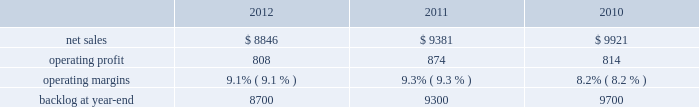Aeronautics 2019 operating profit for 2011 increased $ 132 million , or 9% ( 9 % ) , compared to 2010 .
The increase primarily was attributable to approximately $ 115 million of higher operating profit on c-130 programs due to increased volume and the retirement of risks ; increased volume and risk retirements on f-16 programs of about $ 50 million and c-5 programs of approximately $ 20 million ; and about $ 70 million due to risk retirements on other aeronautics sustainment activities in 2011 .
These increases partially were offset by a decline in operating profit of approximately $ 75 million on the f-22 program and f-35 development contract primarily due to lower volume and about $ 55 million on other programs , including f-35 lrip , primarily due to lower profit rate adjustments in 2011 compared to 2010 .
Adjustments not related to volume , including net profit rate adjustments described above , were approximately $ 90 million higher in 2011 compared to 2010 .
Backlog backlog decreased in 2012 compared to 2011 mainly due to lower orders on f-35 contracts and c-130 programs , partially offset by higher orders on f-16 programs .
Backlog increased in 2011 compared to 2010 mainly due to higher orders on f-35 contracts , which partially were offset by higher sales volume on the c-130 programs .
Trends we expect aeronautics will experience a mid single digit percentage range decline in net sales for 2013 as compared to 2012 .
A decrease in net sales from a decline in f-16 and c-130j aircraft deliveries is expected to be partially offset by an increase in net sales volume on f-35 lrip contracts .
Operating profit is projected to decrease at a high single digit percentage range from 2012 levels due to the expected decline in net sales as well as changes in aircraft mix , resulting in a slight decline in operating margins between the years .
Information systems & global solutions our is&gs business segment provides management services , integrated information technology solutions , and advanced technology systems and expertise across a broad spectrum of applications for civil , defense , intelligence , and other government customers .
Is&gs has a portfolio of many smaller contracts as compared to our other business segments .
Is&gs has been impacted by the continuing downturn in the federal information technology budgets and the impact of the continuing resolution that was effective on october 1 , 2012 , the start of the u.s .
Government 2019s fiscal year .
Is&gs 2019 operating results included the following ( in millions ) : .
2012 compared to 2011 is&gs 2019 net sales for 2012 decreased $ 535 million , or 6% ( 6 % ) , compared to 2011 .
The decrease was attributable to lower net sales of approximately $ 485 million due to the substantial completion of various programs during 2011 ( primarily jtrs ; odin ; and u.k .
Census ) ; and about $ 255 million due to lower volume on numerous other programs ( primarily hanford ; warfighter information network-tactical ( win-t ) ; command , control , battle management and communications ( c2bmc ) ; and transportation worker identification credential ( twic ) ) .
Partially offsetting the decreases were higher net sales of approximately $ 140 million from qtc , which was acquired early in the fourth quarter of 2011 ; and about $ 65 million from increased activity on numerous other programs , primarily federal cyber security programs and persistent threat detection system ( ptds ) operational support .
Is&gs 2019 operating profit for 2012 decreased $ 66 million , or 8% ( 8 % ) , compared to 2011 .
The decrease was attributable to lower operating profit of approximately $ 50 million due to the favorable impact of the odin contract completion in 2011 ; about $ 25 million due to an increase in reserves for performance issues related to an international airborne surveillance system in 2012 ; and approximately $ 20 million due to lower volume on certain programs ( primarily c2bmc and win-t ) .
Partially offsetting the decreases was an increase in operating profit due to higher risk retirements of approximately $ 15 million from the twic program ; and about $ 10 million due to increased activity on numerous other programs , primarily federal cyber security programs and ptds operational support .
Operating profit for the jtrs program was comparable as a decrease in volume was offset by a decrease in reserves .
Adjustments not related to volume , including net profit booking rate adjustments and other matters described above , were approximately $ 20 million higher for 2012 compared to 2011. .
What is the growth rate in net sales for is&gs in 2012? 
Computations: (8846 - 9381)
Answer: -535.0. Aeronautics 2019 operating profit for 2011 increased $ 132 million , or 9% ( 9 % ) , compared to 2010 .
The increase primarily was attributable to approximately $ 115 million of higher operating profit on c-130 programs due to increased volume and the retirement of risks ; increased volume and risk retirements on f-16 programs of about $ 50 million and c-5 programs of approximately $ 20 million ; and about $ 70 million due to risk retirements on other aeronautics sustainment activities in 2011 .
These increases partially were offset by a decline in operating profit of approximately $ 75 million on the f-22 program and f-35 development contract primarily due to lower volume and about $ 55 million on other programs , including f-35 lrip , primarily due to lower profit rate adjustments in 2011 compared to 2010 .
Adjustments not related to volume , including net profit rate adjustments described above , were approximately $ 90 million higher in 2011 compared to 2010 .
Backlog backlog decreased in 2012 compared to 2011 mainly due to lower orders on f-35 contracts and c-130 programs , partially offset by higher orders on f-16 programs .
Backlog increased in 2011 compared to 2010 mainly due to higher orders on f-35 contracts , which partially were offset by higher sales volume on the c-130 programs .
Trends we expect aeronautics will experience a mid single digit percentage range decline in net sales for 2013 as compared to 2012 .
A decrease in net sales from a decline in f-16 and c-130j aircraft deliveries is expected to be partially offset by an increase in net sales volume on f-35 lrip contracts .
Operating profit is projected to decrease at a high single digit percentage range from 2012 levels due to the expected decline in net sales as well as changes in aircraft mix , resulting in a slight decline in operating margins between the years .
Information systems & global solutions our is&gs business segment provides management services , integrated information technology solutions , and advanced technology systems and expertise across a broad spectrum of applications for civil , defense , intelligence , and other government customers .
Is&gs has a portfolio of many smaller contracts as compared to our other business segments .
Is&gs has been impacted by the continuing downturn in the federal information technology budgets and the impact of the continuing resolution that was effective on october 1 , 2012 , the start of the u.s .
Government 2019s fiscal year .
Is&gs 2019 operating results included the following ( in millions ) : .
2012 compared to 2011 is&gs 2019 net sales for 2012 decreased $ 535 million , or 6% ( 6 % ) , compared to 2011 .
The decrease was attributable to lower net sales of approximately $ 485 million due to the substantial completion of various programs during 2011 ( primarily jtrs ; odin ; and u.k .
Census ) ; and about $ 255 million due to lower volume on numerous other programs ( primarily hanford ; warfighter information network-tactical ( win-t ) ; command , control , battle management and communications ( c2bmc ) ; and transportation worker identification credential ( twic ) ) .
Partially offsetting the decreases were higher net sales of approximately $ 140 million from qtc , which was acquired early in the fourth quarter of 2011 ; and about $ 65 million from increased activity on numerous other programs , primarily federal cyber security programs and persistent threat detection system ( ptds ) operational support .
Is&gs 2019 operating profit for 2012 decreased $ 66 million , or 8% ( 8 % ) , compared to 2011 .
The decrease was attributable to lower operating profit of approximately $ 50 million due to the favorable impact of the odin contract completion in 2011 ; about $ 25 million due to an increase in reserves for performance issues related to an international airborne surveillance system in 2012 ; and approximately $ 20 million due to lower volume on certain programs ( primarily c2bmc and win-t ) .
Partially offsetting the decreases was an increase in operating profit due to higher risk retirements of approximately $ 15 million from the twic program ; and about $ 10 million due to increased activity on numerous other programs , primarily federal cyber security programs and ptds operational support .
Operating profit for the jtrs program was comparable as a decrease in volume was offset by a decrease in reserves .
Adjustments not related to volume , including net profit booking rate adjustments and other matters described above , were approximately $ 20 million higher for 2012 compared to 2011. .
What was the percent of the lowered net sales in 2012 attributable to the substantial completion of various programs during 2011 \\n\\n? 
Computations: (485 / 535)
Answer: 0.90654. 